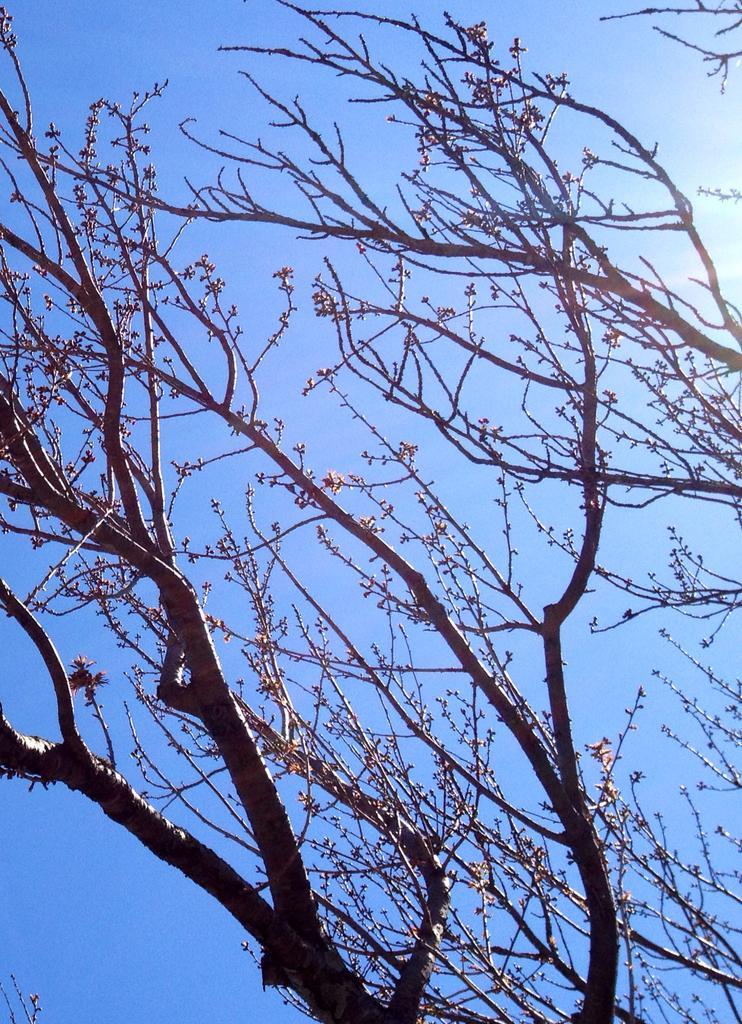Can you describe this image briefly? In this picture I can see the trees in front and in the background I can see the clear sky. 